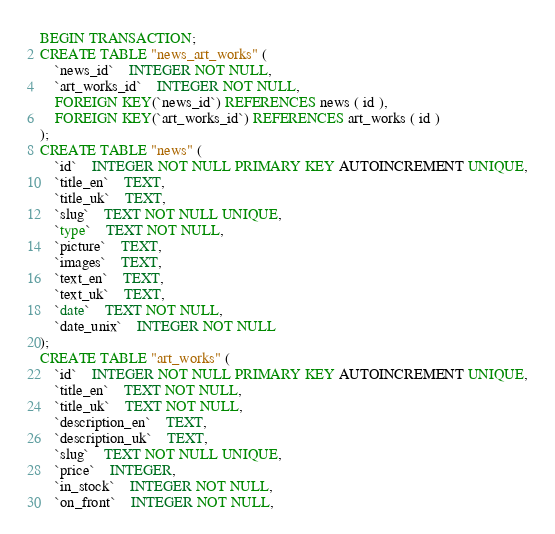<code> <loc_0><loc_0><loc_500><loc_500><_SQL_>BEGIN TRANSACTION;
CREATE TABLE "news_art_works" (
	`news_id`	INTEGER NOT NULL,
	`art_works_id`	INTEGER NOT NULL,
	FOREIGN KEY(`news_id`) REFERENCES news ( id ),
	FOREIGN KEY(`art_works_id`) REFERENCES art_works ( id )
);
CREATE TABLE "news" (
	`id`	INTEGER NOT NULL PRIMARY KEY AUTOINCREMENT UNIQUE,
	`title_en`	TEXT,
	`title_uk`	TEXT,
	`slug`	TEXT NOT NULL UNIQUE,
	`type`	TEXT NOT NULL,
	`picture`	TEXT,
	`images`	TEXT,
	`text_en`	TEXT,
	`text_uk`	TEXT,
	`date`	TEXT NOT NULL,
	`date_unix`	INTEGER NOT NULL
);
CREATE TABLE "art_works" (
	`id`	INTEGER NOT NULL PRIMARY KEY AUTOINCREMENT UNIQUE,
	`title_en`	TEXT NOT NULL,
	`title_uk`	TEXT NOT NULL,
	`description_en`	TEXT,
	`description_uk`	TEXT,
	`slug`	TEXT NOT NULL UNIQUE,
	`price`	INTEGER,
	`in_stock`	INTEGER NOT NULL,
	`on_front`	INTEGER NOT NULL,</code> 